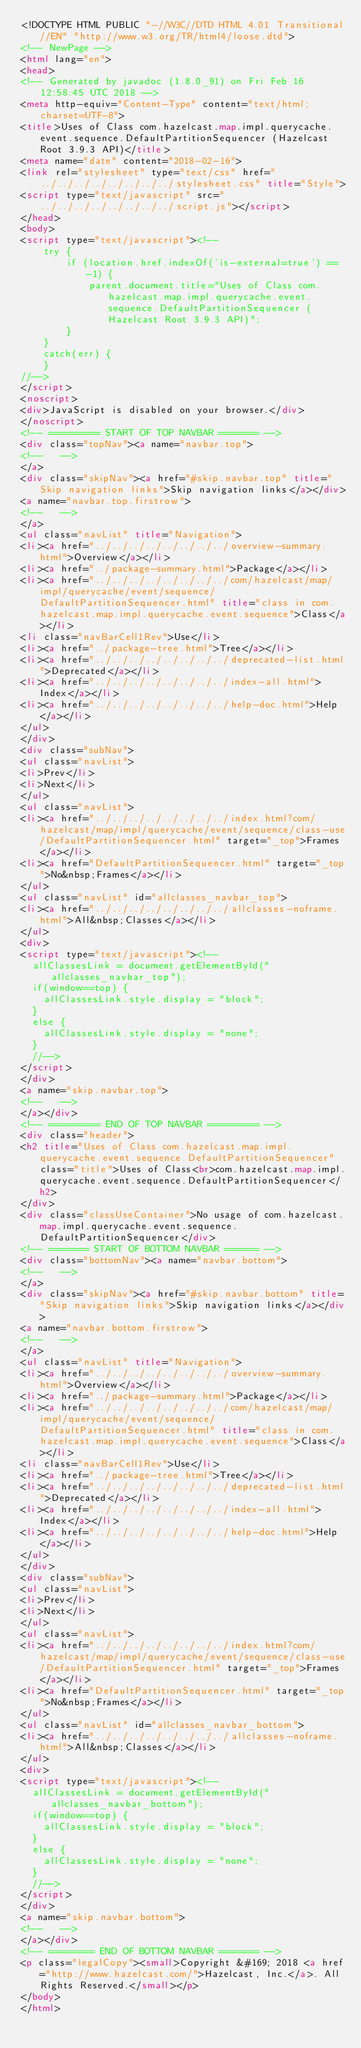<code> <loc_0><loc_0><loc_500><loc_500><_HTML_><!DOCTYPE HTML PUBLIC "-//W3C//DTD HTML 4.01 Transitional//EN" "http://www.w3.org/TR/html4/loose.dtd">
<!-- NewPage -->
<html lang="en">
<head>
<!-- Generated by javadoc (1.8.0_91) on Fri Feb 16 12:58:45 UTC 2018 -->
<meta http-equiv="Content-Type" content="text/html; charset=UTF-8">
<title>Uses of Class com.hazelcast.map.impl.querycache.event.sequence.DefaultPartitionSequencer (Hazelcast Root 3.9.3 API)</title>
<meta name="date" content="2018-02-16">
<link rel="stylesheet" type="text/css" href="../../../../../../../../stylesheet.css" title="Style">
<script type="text/javascript" src="../../../../../../../../script.js"></script>
</head>
<body>
<script type="text/javascript"><!--
    try {
        if (location.href.indexOf('is-external=true') == -1) {
            parent.document.title="Uses of Class com.hazelcast.map.impl.querycache.event.sequence.DefaultPartitionSequencer (Hazelcast Root 3.9.3 API)";
        }
    }
    catch(err) {
    }
//-->
</script>
<noscript>
<div>JavaScript is disabled on your browser.</div>
</noscript>
<!-- ========= START OF TOP NAVBAR ======= -->
<div class="topNav"><a name="navbar.top">
<!--   -->
</a>
<div class="skipNav"><a href="#skip.navbar.top" title="Skip navigation links">Skip navigation links</a></div>
<a name="navbar.top.firstrow">
<!--   -->
</a>
<ul class="navList" title="Navigation">
<li><a href="../../../../../../../../overview-summary.html">Overview</a></li>
<li><a href="../package-summary.html">Package</a></li>
<li><a href="../../../../../../../../com/hazelcast/map/impl/querycache/event/sequence/DefaultPartitionSequencer.html" title="class in com.hazelcast.map.impl.querycache.event.sequence">Class</a></li>
<li class="navBarCell1Rev">Use</li>
<li><a href="../package-tree.html">Tree</a></li>
<li><a href="../../../../../../../../deprecated-list.html">Deprecated</a></li>
<li><a href="../../../../../../../../index-all.html">Index</a></li>
<li><a href="../../../../../../../../help-doc.html">Help</a></li>
</ul>
</div>
<div class="subNav">
<ul class="navList">
<li>Prev</li>
<li>Next</li>
</ul>
<ul class="navList">
<li><a href="../../../../../../../../index.html?com/hazelcast/map/impl/querycache/event/sequence/class-use/DefaultPartitionSequencer.html" target="_top">Frames</a></li>
<li><a href="DefaultPartitionSequencer.html" target="_top">No&nbsp;Frames</a></li>
</ul>
<ul class="navList" id="allclasses_navbar_top">
<li><a href="../../../../../../../../allclasses-noframe.html">All&nbsp;Classes</a></li>
</ul>
<div>
<script type="text/javascript"><!--
  allClassesLink = document.getElementById("allclasses_navbar_top");
  if(window==top) {
    allClassesLink.style.display = "block";
  }
  else {
    allClassesLink.style.display = "none";
  }
  //-->
</script>
</div>
<a name="skip.navbar.top">
<!--   -->
</a></div>
<!-- ========= END OF TOP NAVBAR ========= -->
<div class="header">
<h2 title="Uses of Class com.hazelcast.map.impl.querycache.event.sequence.DefaultPartitionSequencer" class="title">Uses of Class<br>com.hazelcast.map.impl.querycache.event.sequence.DefaultPartitionSequencer</h2>
</div>
<div class="classUseContainer">No usage of com.hazelcast.map.impl.querycache.event.sequence.DefaultPartitionSequencer</div>
<!-- ======= START OF BOTTOM NAVBAR ====== -->
<div class="bottomNav"><a name="navbar.bottom">
<!--   -->
</a>
<div class="skipNav"><a href="#skip.navbar.bottom" title="Skip navigation links">Skip navigation links</a></div>
<a name="navbar.bottom.firstrow">
<!--   -->
</a>
<ul class="navList" title="Navigation">
<li><a href="../../../../../../../../overview-summary.html">Overview</a></li>
<li><a href="../package-summary.html">Package</a></li>
<li><a href="../../../../../../../../com/hazelcast/map/impl/querycache/event/sequence/DefaultPartitionSequencer.html" title="class in com.hazelcast.map.impl.querycache.event.sequence">Class</a></li>
<li class="navBarCell1Rev">Use</li>
<li><a href="../package-tree.html">Tree</a></li>
<li><a href="../../../../../../../../deprecated-list.html">Deprecated</a></li>
<li><a href="../../../../../../../../index-all.html">Index</a></li>
<li><a href="../../../../../../../../help-doc.html">Help</a></li>
</ul>
</div>
<div class="subNav">
<ul class="navList">
<li>Prev</li>
<li>Next</li>
</ul>
<ul class="navList">
<li><a href="../../../../../../../../index.html?com/hazelcast/map/impl/querycache/event/sequence/class-use/DefaultPartitionSequencer.html" target="_top">Frames</a></li>
<li><a href="DefaultPartitionSequencer.html" target="_top">No&nbsp;Frames</a></li>
</ul>
<ul class="navList" id="allclasses_navbar_bottom">
<li><a href="../../../../../../../../allclasses-noframe.html">All&nbsp;Classes</a></li>
</ul>
<div>
<script type="text/javascript"><!--
  allClassesLink = document.getElementById("allclasses_navbar_bottom");
  if(window==top) {
    allClassesLink.style.display = "block";
  }
  else {
    allClassesLink.style.display = "none";
  }
  //-->
</script>
</div>
<a name="skip.navbar.bottom">
<!--   -->
</a></div>
<!-- ======== END OF BOTTOM NAVBAR ======= -->
<p class="legalCopy"><small>Copyright &#169; 2018 <a href="http://www.hazelcast.com/">Hazelcast, Inc.</a>. All Rights Reserved.</small></p>
</body>
</html>
</code> 